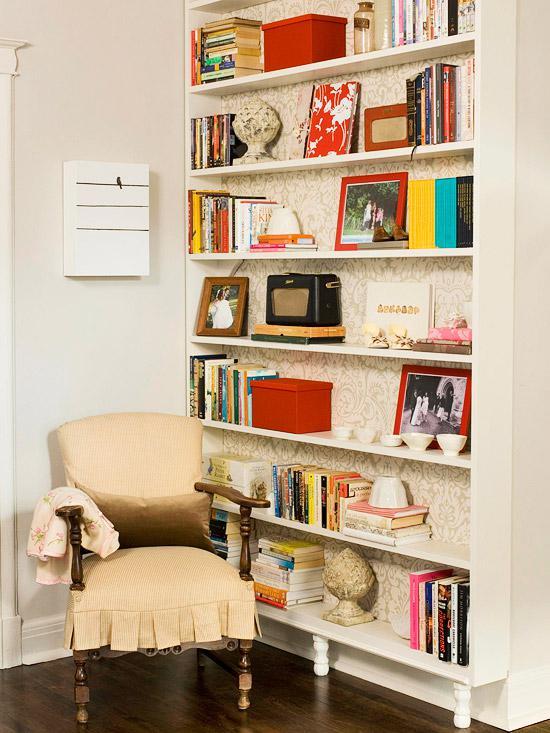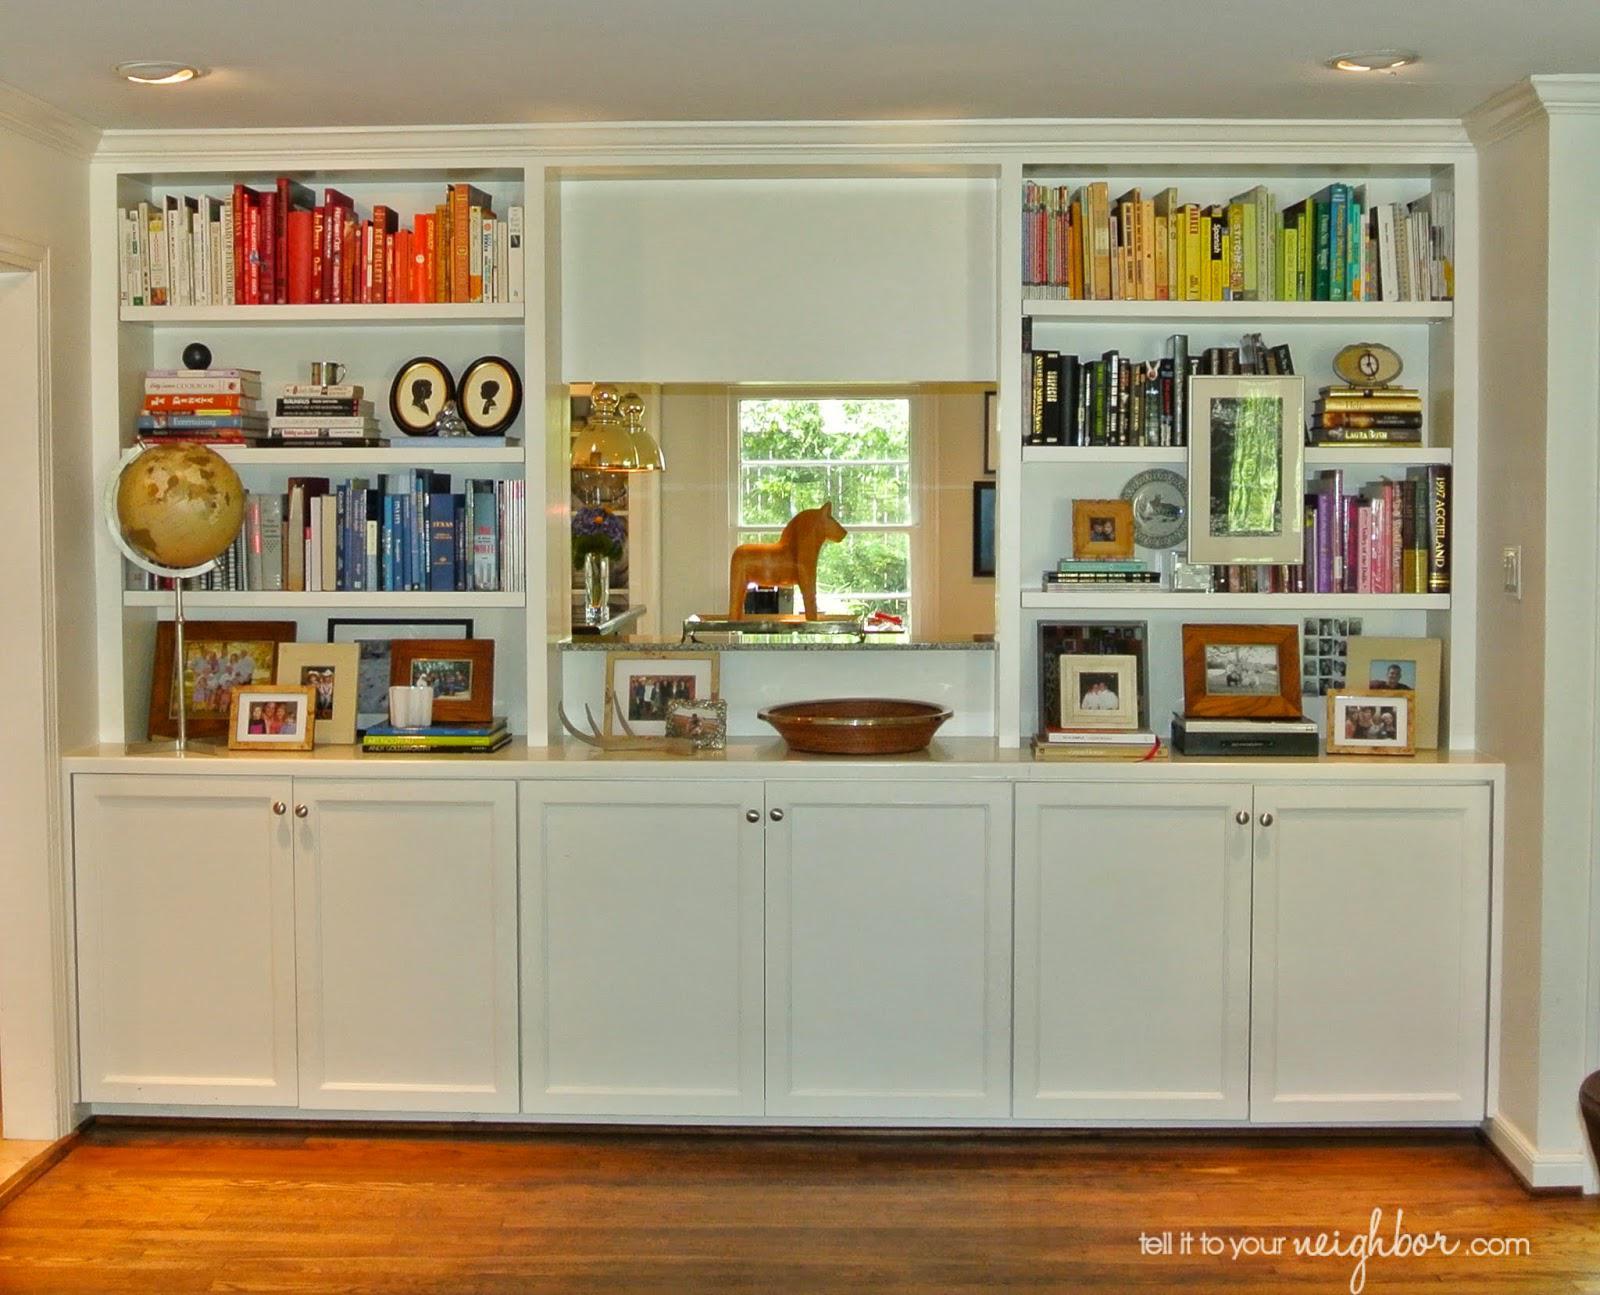The first image is the image on the left, the second image is the image on the right. Examine the images to the left and right. Is the description "Each bookshelf is freestanding." accurate? Answer yes or no. No. The first image is the image on the left, the second image is the image on the right. Assess this claim about the two images: "There are at least three bookshelves made in to one that take up the wall of a room.". Correct or not? Answer yes or no. Yes. 